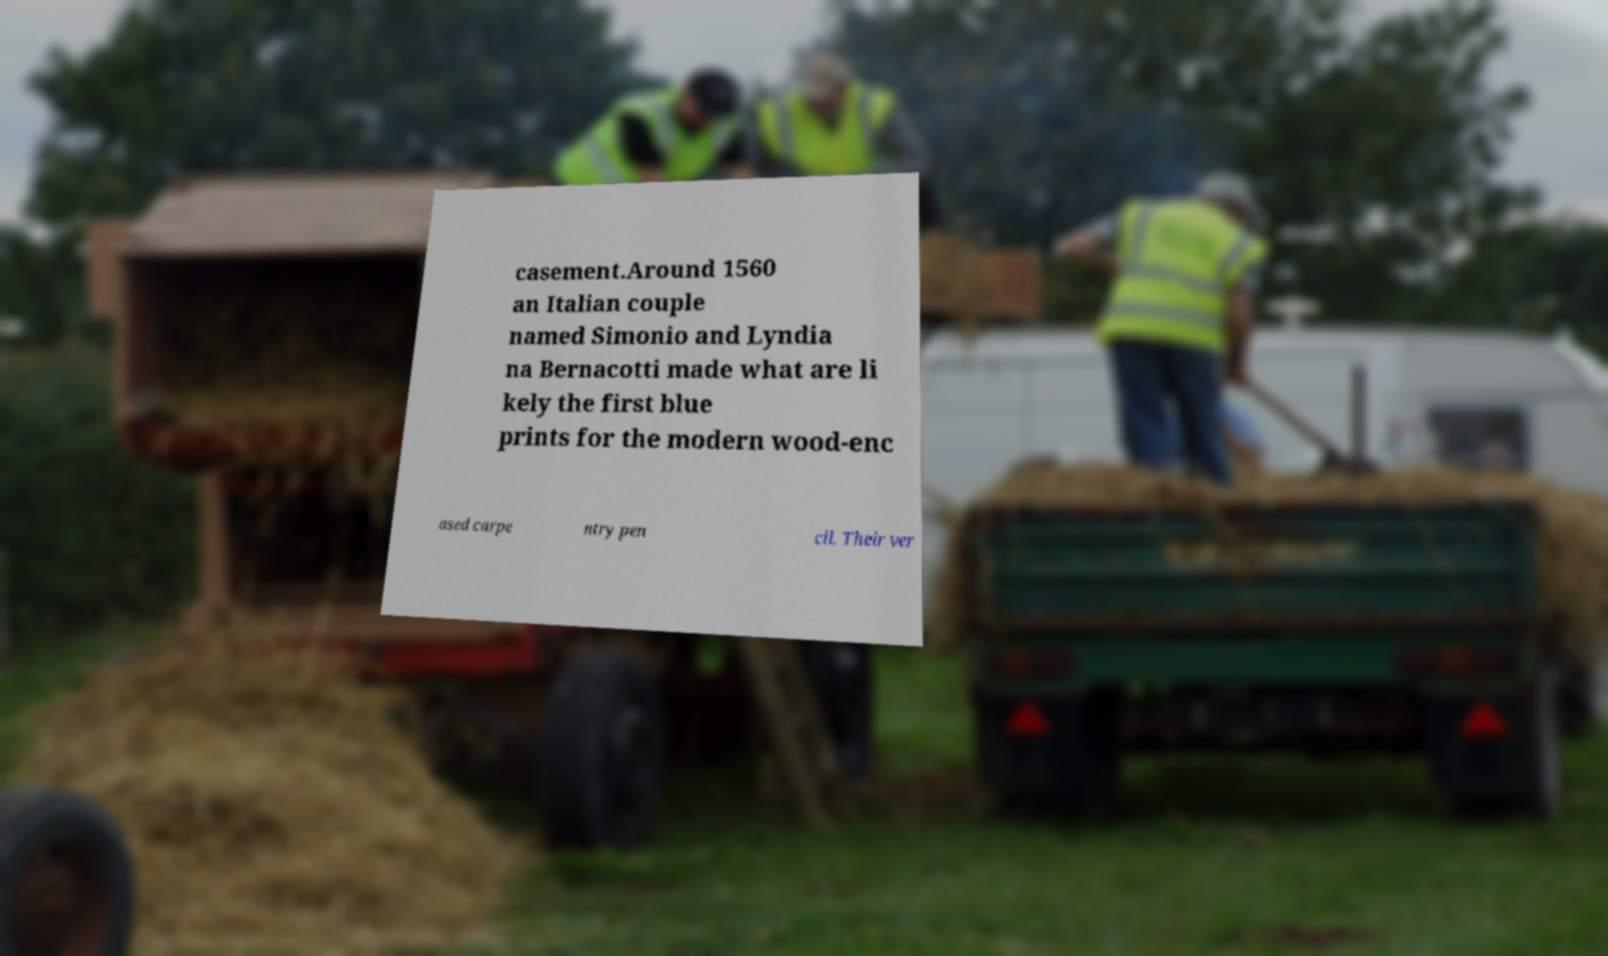I need the written content from this picture converted into text. Can you do that? casement.Around 1560 an Italian couple named Simonio and Lyndia na Bernacotti made what are li kely the first blue prints for the modern wood-enc ased carpe ntry pen cil. Their ver 